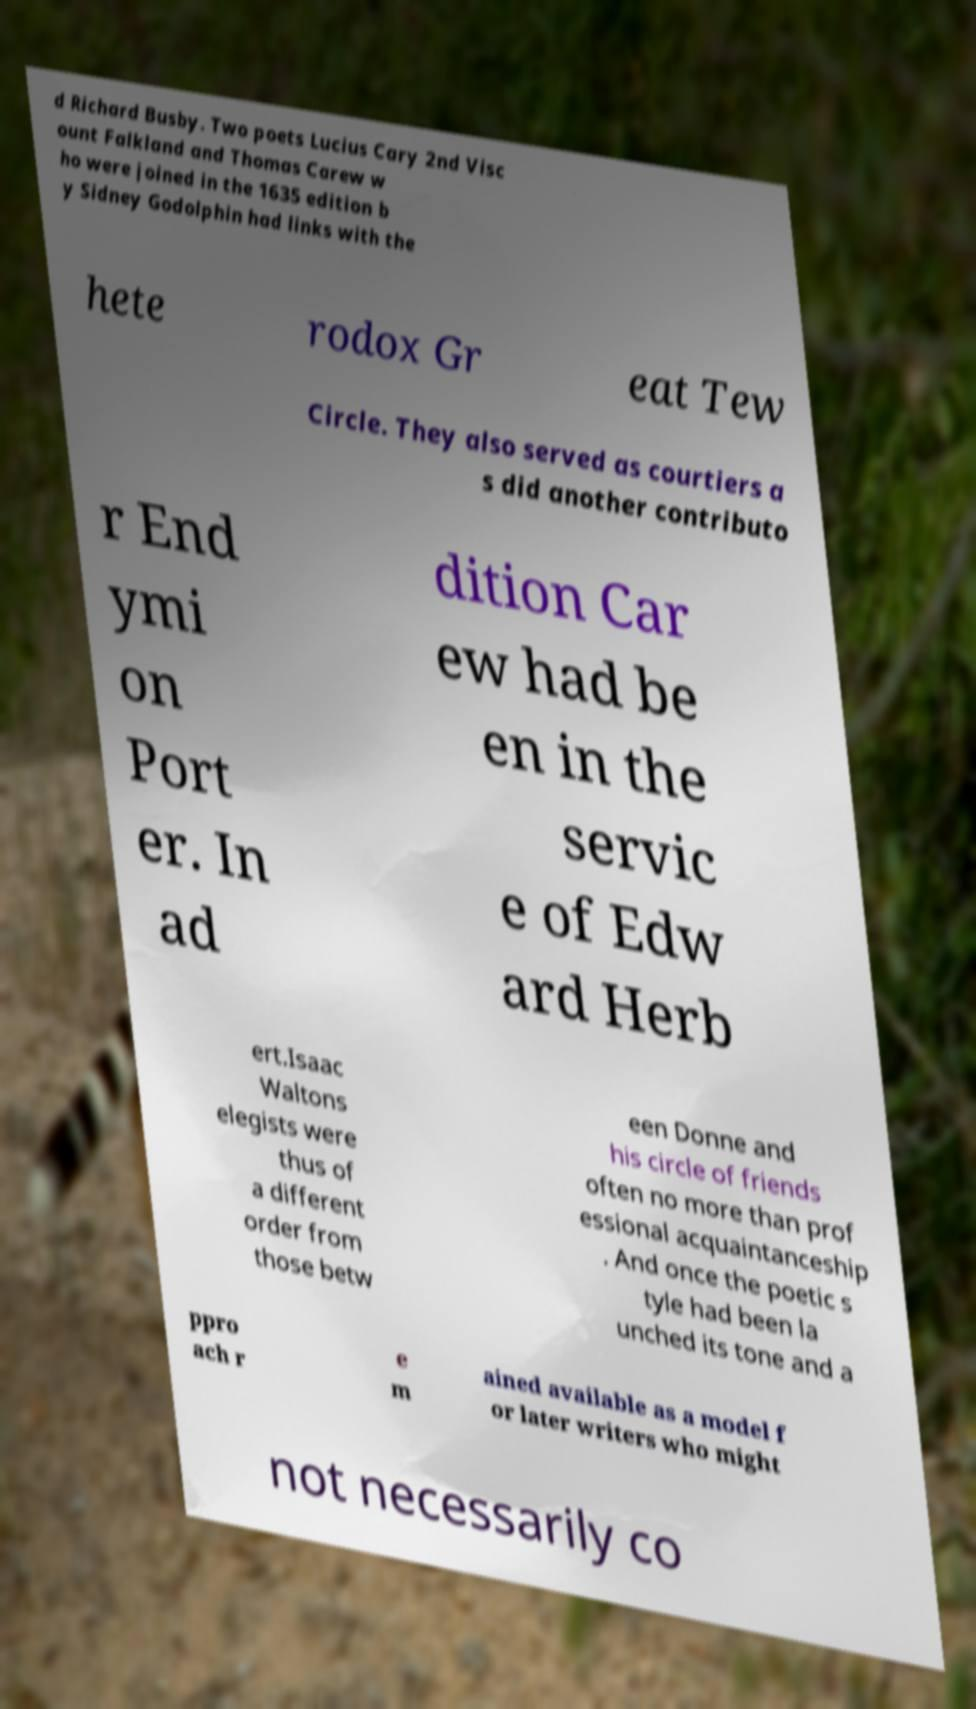Can you read and provide the text displayed in the image?This photo seems to have some interesting text. Can you extract and type it out for me? d Richard Busby. Two poets Lucius Cary 2nd Visc ount Falkland and Thomas Carew w ho were joined in the 1635 edition b y Sidney Godolphin had links with the hete rodox Gr eat Tew Circle. They also served as courtiers a s did another contributo r End ymi on Port er. In ad dition Car ew had be en in the servic e of Edw ard Herb ert.Isaac Waltons elegists were thus of a different order from those betw een Donne and his circle of friends often no more than prof essional acquaintanceship . And once the poetic s tyle had been la unched its tone and a ppro ach r e m ained available as a model f or later writers who might not necessarily co 